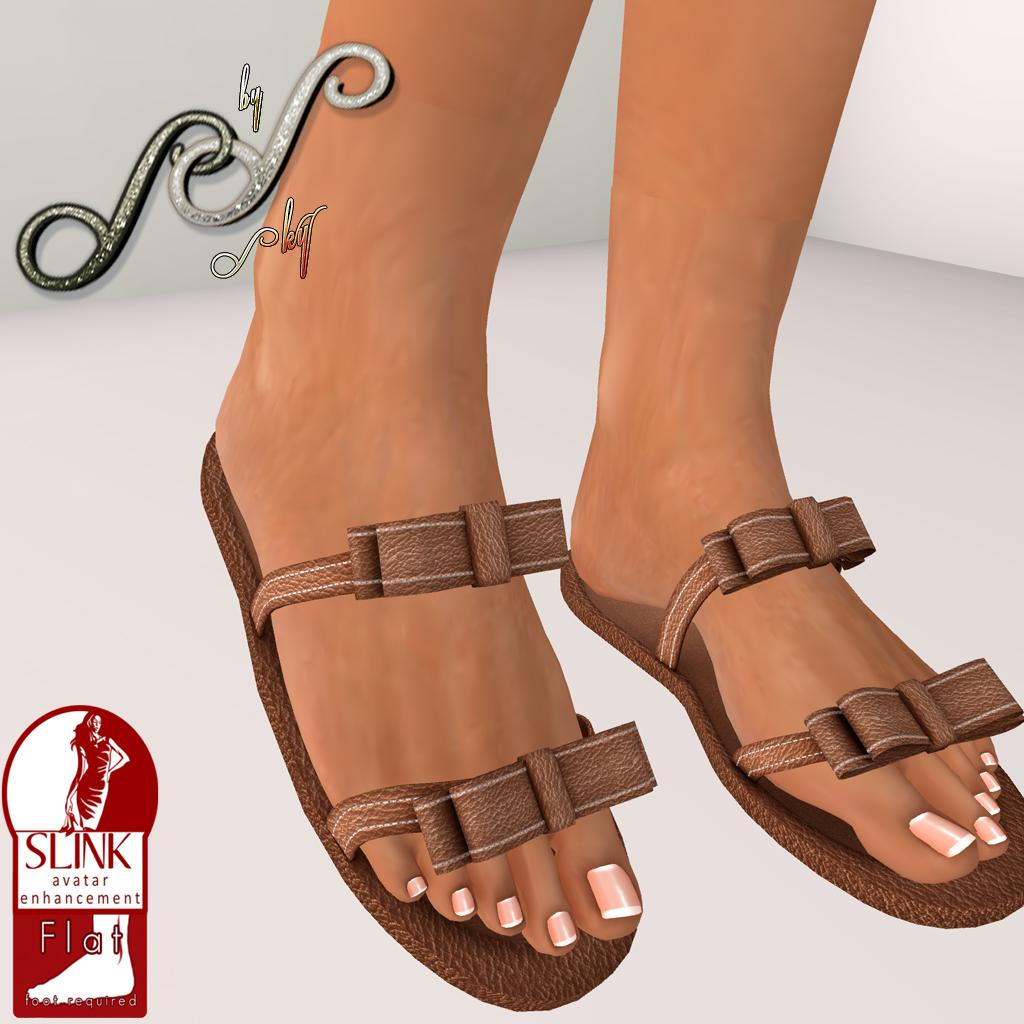What type of art is featured in the image? The image contains digital art. Can you describe any human elements in the image? The legs of a person are visible in the image. What can be said about the person's footwear? The person's legs are wearing footwear, which is brown in color. What is the color of the background in the image? The background of the image is white. What type of tooth can be seen in the image? There is no tooth present in the image; it features digital art with a person's legs and footwear. Can you describe the brick structure in the image? There is no brick structure present in the image; it features digital art with a person's legs and footwear against a white background. 